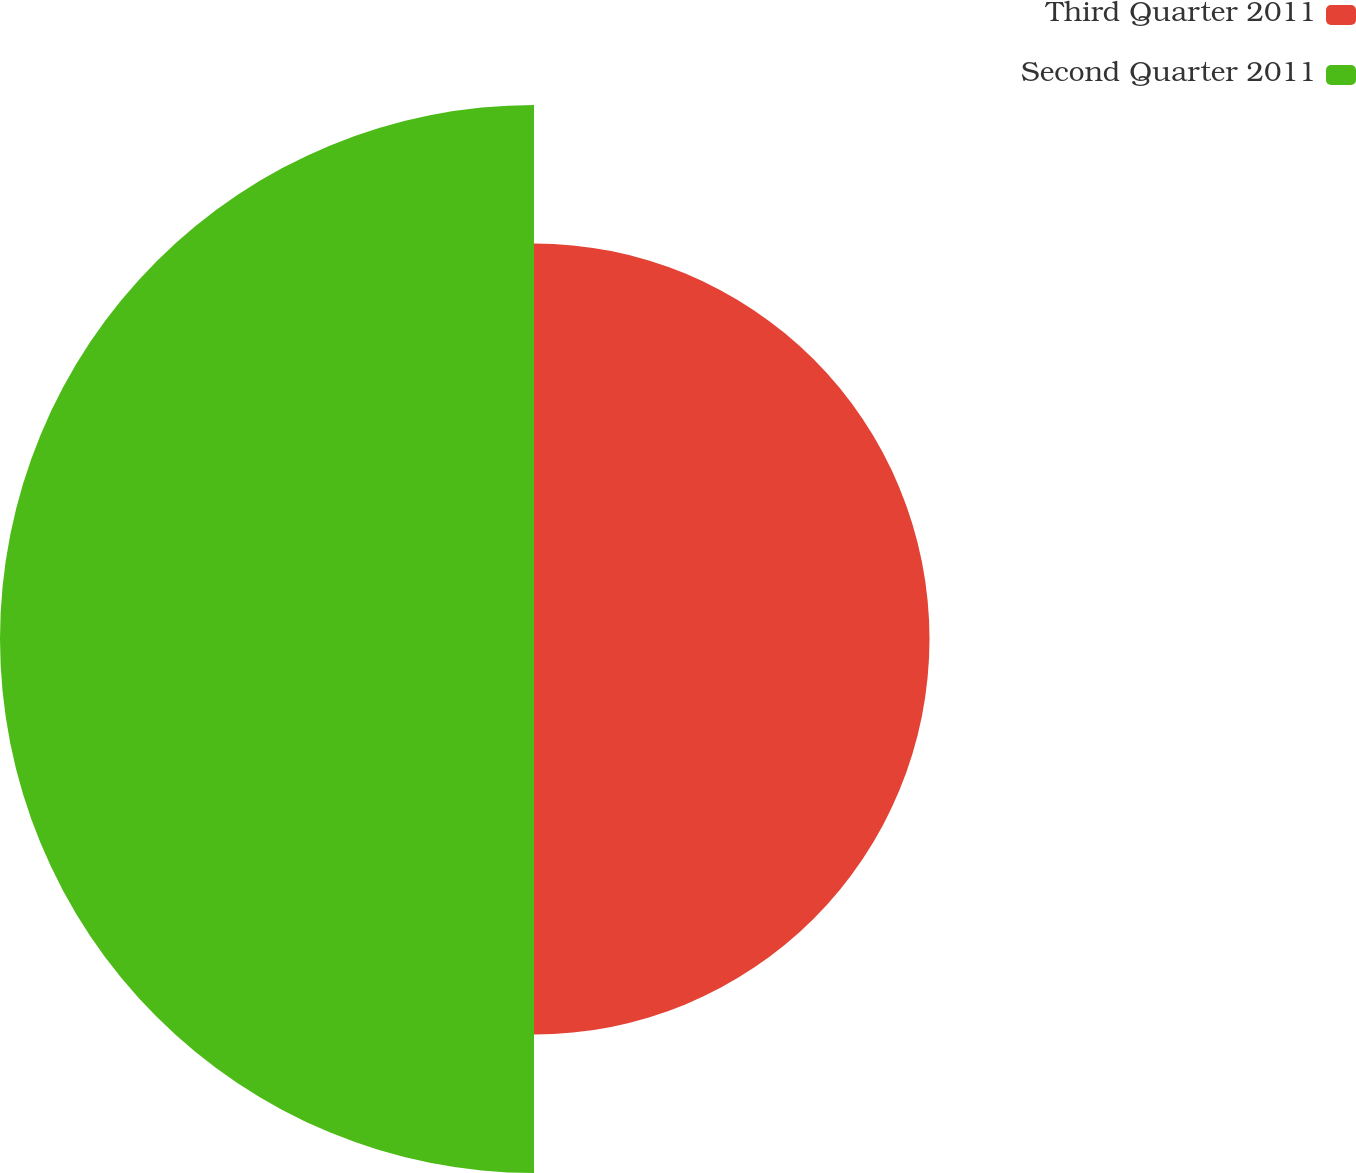Convert chart to OTSL. <chart><loc_0><loc_0><loc_500><loc_500><pie_chart><fcel>Third Quarter 2011<fcel>Second Quarter 2011<nl><fcel>42.55%<fcel>57.45%<nl></chart> 